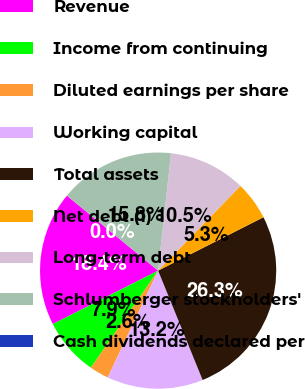Convert chart to OTSL. <chart><loc_0><loc_0><loc_500><loc_500><pie_chart><fcel>Revenue<fcel>Income from continuing<fcel>Diluted earnings per share<fcel>Working capital<fcel>Total assets<fcel>Net debt (1)<fcel>Long-term debt<fcel>Schlumberger stockholders'<fcel>Cash dividends declared per<nl><fcel>18.42%<fcel>7.89%<fcel>2.63%<fcel>13.16%<fcel>26.32%<fcel>5.26%<fcel>10.53%<fcel>15.79%<fcel>0.0%<nl></chart> 